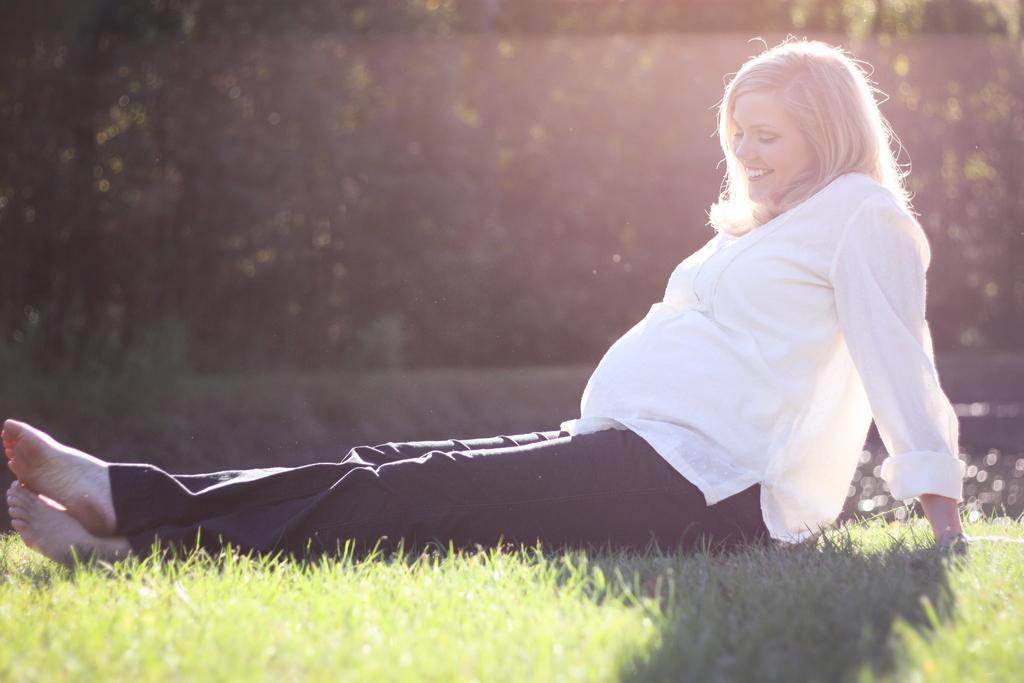What is the main subject of the image? The main subject of the image is a pregnant lady. Where is the pregnant lady located in the image? The pregnant lady is sitting on the grass. What is the pregnant lady's expression in the image? The pregnant lady is smiling. What can be seen in the background of the image? There are trees visible in the image. Can you see any lizards crawling on the pregnant lady's mitten near the ocean in the image? There is no mitten, lizards, or ocean present in the image. 